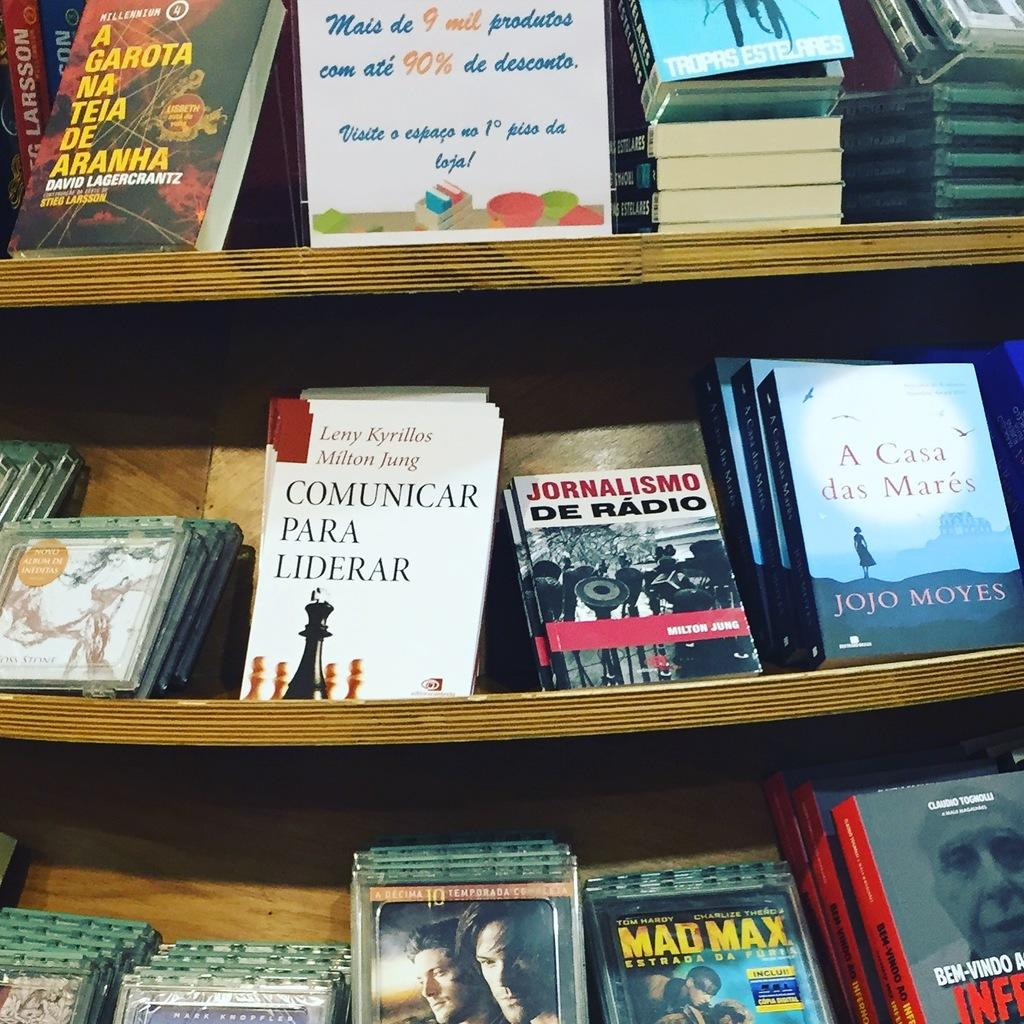<image>
Offer a succinct explanation of the picture presented. The movie Mad Max sits on a bottom shelf at some kind of store 